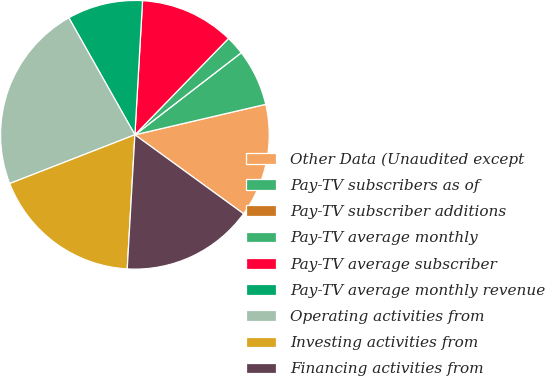<chart> <loc_0><loc_0><loc_500><loc_500><pie_chart><fcel>Other Data (Unaudited except<fcel>Pay-TV subscribers as of<fcel>Pay-TV subscriber additions<fcel>Pay-TV average monthly<fcel>Pay-TV average subscriber<fcel>Pay-TV average monthly revenue<fcel>Operating activities from<fcel>Investing activities from<fcel>Financing activities from<nl><fcel>13.64%<fcel>6.82%<fcel>0.0%<fcel>2.27%<fcel>11.36%<fcel>9.09%<fcel>22.73%<fcel>18.18%<fcel>15.91%<nl></chart> 